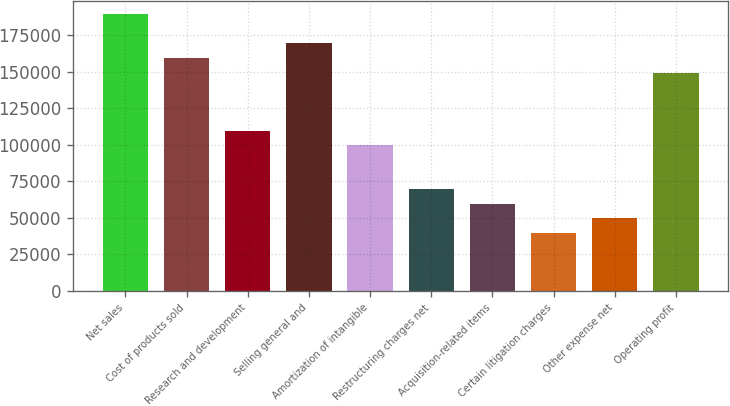Convert chart. <chart><loc_0><loc_0><loc_500><loc_500><bar_chart><fcel>Net sales<fcel>Cost of products sold<fcel>Research and development<fcel>Selling general and<fcel>Amortization of intangible<fcel>Restructuring charges net<fcel>Acquisition-related items<fcel>Certain litigation charges<fcel>Other expense net<fcel>Operating profit<nl><fcel>189400<fcel>159495<fcel>109653<fcel>169463<fcel>99685<fcel>69780<fcel>59811.6<fcel>39874.9<fcel>49843.3<fcel>149527<nl></chart> 